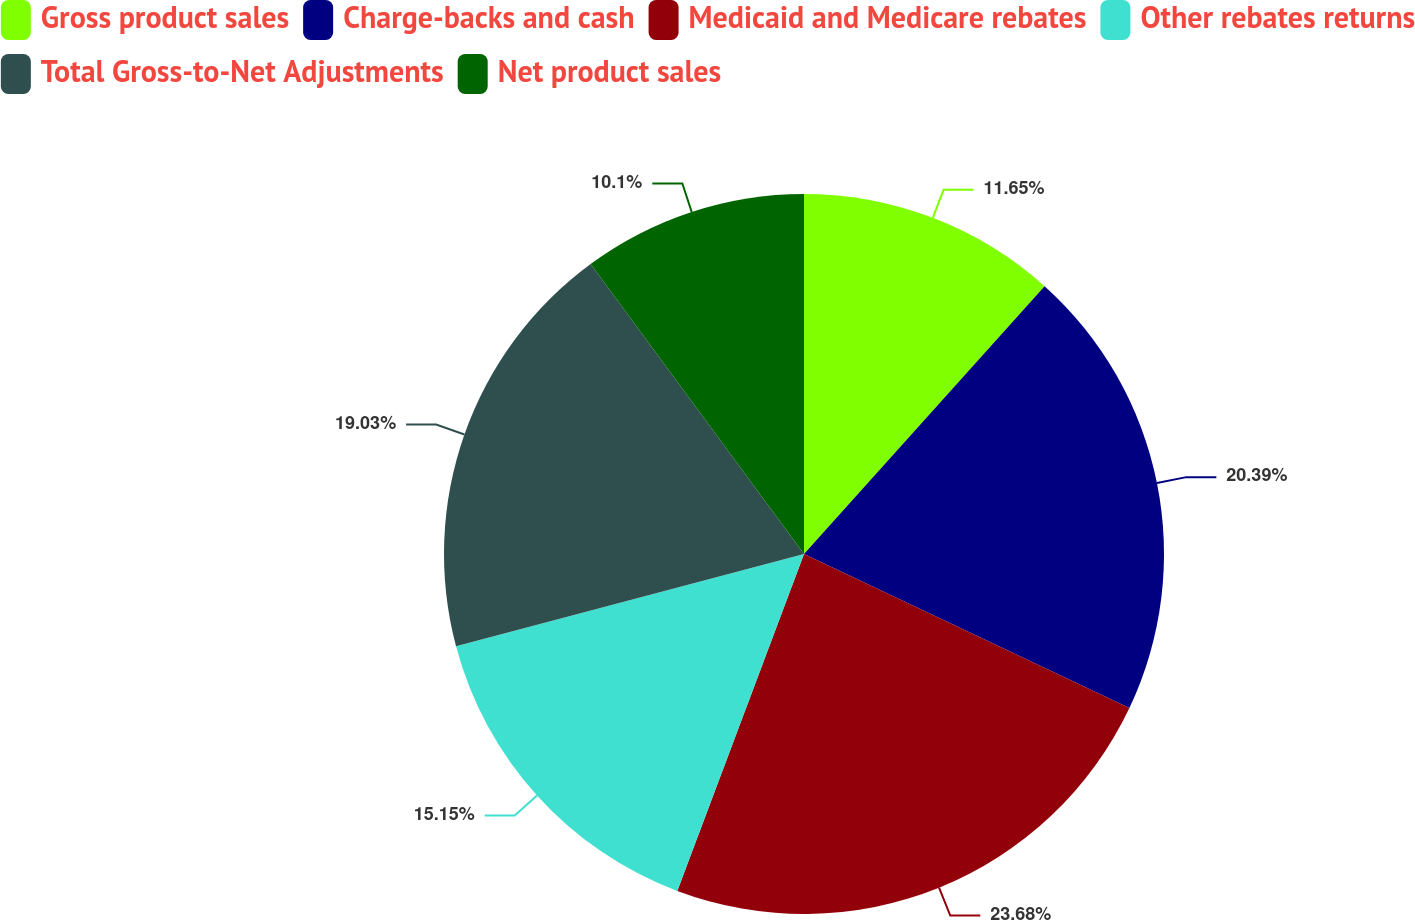Convert chart. <chart><loc_0><loc_0><loc_500><loc_500><pie_chart><fcel>Gross product sales<fcel>Charge-backs and cash<fcel>Medicaid and Medicare rebates<fcel>Other rebates returns<fcel>Total Gross-to-Net Adjustments<fcel>Net product sales<nl><fcel>11.65%<fcel>20.39%<fcel>23.69%<fcel>15.15%<fcel>19.03%<fcel>10.1%<nl></chart> 